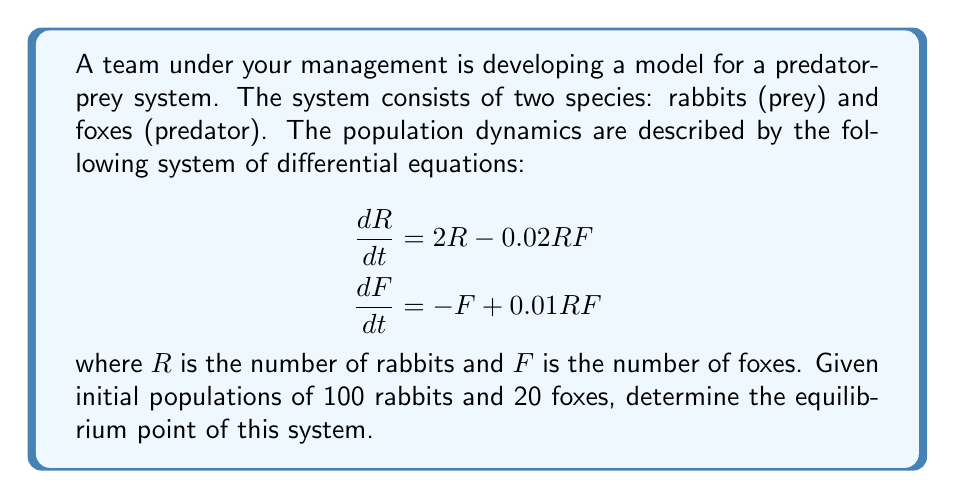Give your solution to this math problem. To find the equilibrium point, we need to set both derivatives to zero and solve the resulting system of equations:

1) Set $\frac{dR}{dt} = 0$ and $\frac{dF}{dt} = 0$:

   $$\begin{aligned}
   0 &= 2R - 0.02RF \\
   0 &= -F + 0.01RF
   \end{aligned}$$

2) From the second equation:
   
   $F = 0.01RF$

3) Substitute this into the first equation:
   
   $0 = 2R - 0.02R(0.01RF) = 2R - 0.0002R^2F$

4) Factor out R:
   
   $R(2 - 0.0002RF) = 0$

5) This equation is satisfied when either $R = 0$ or $2 - 0.0002RF = 0$. 
   The trivial solution $R = 0$ implies $F = 0$, which is not interesting.
   Let's solve $2 - 0.0002RF = 0$:

   $RF = 10000$

6) Substitute this back into $F = 0.01RF$:
   
   $F = 0.01R(10000) = 100R$

7) Now we have two equations:
   
   $$\begin{aligned}
   RF &= 10000 \\
   F &= 100
   \end{aligned}$$

8) Substituting the second into the first:
   
   $R(100) = 10000$
   $R = 100$

Therefore, the equilibrium point is $(R, F) = (100, 100)$.
Answer: $(100, 100)$ 